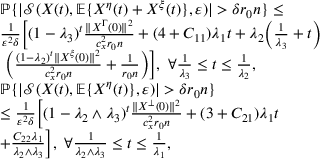Convert formula to latex. <formula><loc_0><loc_0><loc_500><loc_500>\begin{array} { r l } & { \mathbb { P } \{ | \mathcal { S } ( X ( t ) , \mathbb { E } \{ X ^ { \eta } ( t ) + X ^ { \xi } ( t ) \} , \varepsilon ) | > \delta r _ { 0 } n \} \leq } \\ & { \frac { 1 } { \varepsilon ^ { 2 } \delta } \left [ ( 1 - \lambda _ { 3 } ) ^ { t } \frac { \| X ^ { \Gamma } ( 0 ) \| ^ { 2 } } { c _ { x } ^ { 2 } r _ { 0 } n } + ( 4 + C _ { 1 1 } ) \lambda _ { 1 } t + \lambda _ { 2 } \left ( \frac { 1 } { \lambda _ { 3 } } + t \right ) } \\ & { \left ( \frac { ( 1 - \lambda _ { 2 } ) ^ { t } \| X ^ { \xi } ( 0 ) \| ^ { 2 } } { c _ { x } ^ { 2 } r _ { 0 } n } + \frac { 1 } { r _ { 0 } n } \right ) \right ] , \forall \frac { 1 } { \lambda _ { 3 } } \leq t \leq \frac { 1 } { \lambda _ { 2 } } , } \\ & { \mathbb { P } \{ | \mathcal { S } ( X ( t ) , \mathbb { E } \{ X ^ { \eta } ( t ) \} , \varepsilon ) | > \delta r _ { 0 } n \} } \\ & { \leq \frac { 1 } { \varepsilon ^ { 2 } \delta } \left [ ( 1 - \lambda _ { 2 } \wedge \lambda _ { 3 } ) ^ { t } \frac { \| X ^ { \bot } ( 0 ) \| ^ { 2 } } { c _ { x } ^ { 2 } r _ { 0 } n } + ( 3 + C _ { 2 1 } ) \lambda _ { 1 } t } \\ & { + \frac { C _ { 2 2 } \lambda _ { 1 } } { \lambda _ { 2 } \wedge \lambda _ { 3 } } \right ] , \forall \frac { 1 } { \lambda _ { 2 } \wedge \lambda _ { 3 } } \leq t \leq \frac { 1 } { \lambda _ { 1 } } , } \end{array}</formula> 